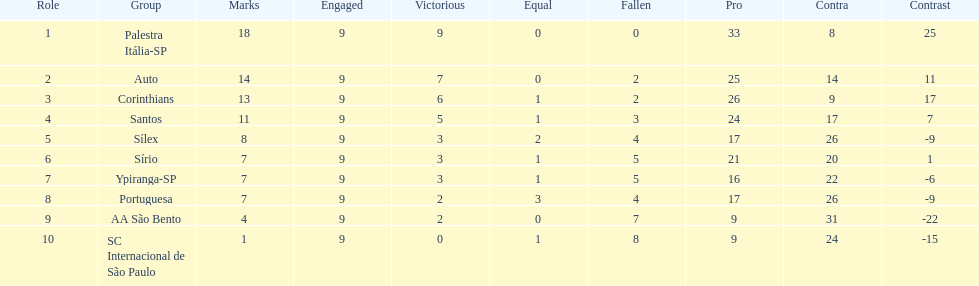In 1926 brazilian football, how many teams scored above 10 points in the season? 4. 